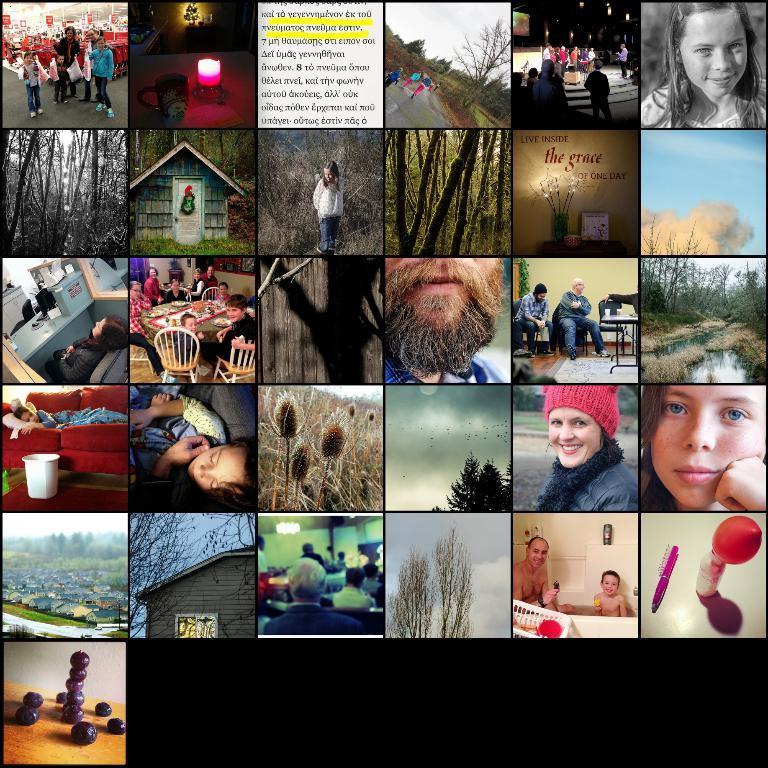Can you describe this image briefly? This picture is consists of a collage of photographs in the image. 